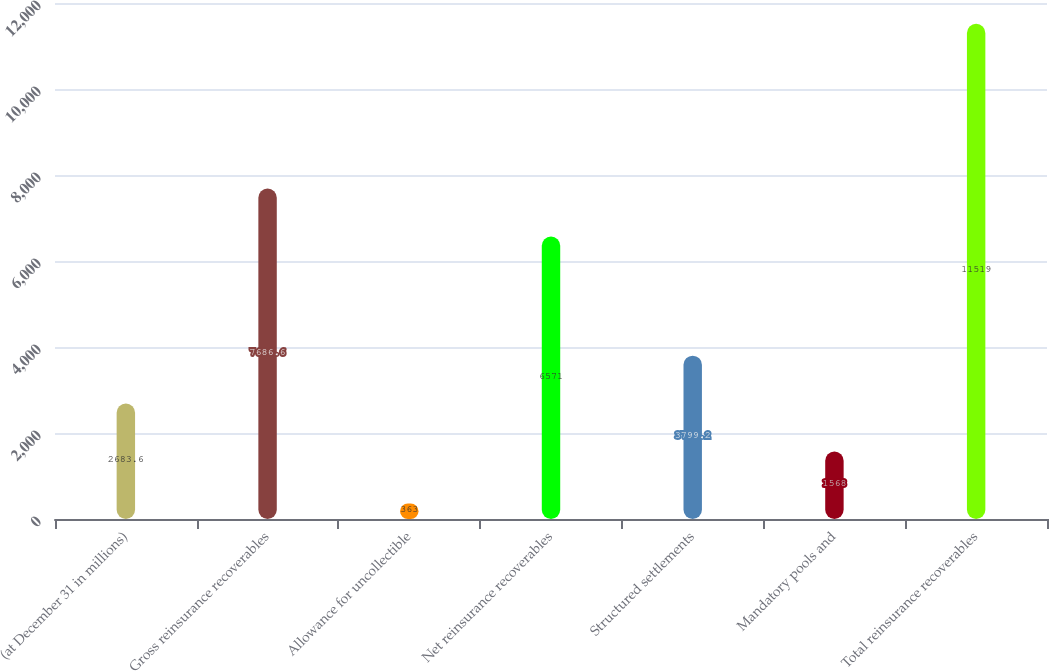<chart> <loc_0><loc_0><loc_500><loc_500><bar_chart><fcel>(at December 31 in millions)<fcel>Gross reinsurance recoverables<fcel>Allowance for uncollectible<fcel>Net reinsurance recoverables<fcel>Structured settlements<fcel>Mandatory pools and<fcel>Total reinsurance recoverables<nl><fcel>2683.6<fcel>7686.6<fcel>363<fcel>6571<fcel>3799.2<fcel>1568<fcel>11519<nl></chart> 